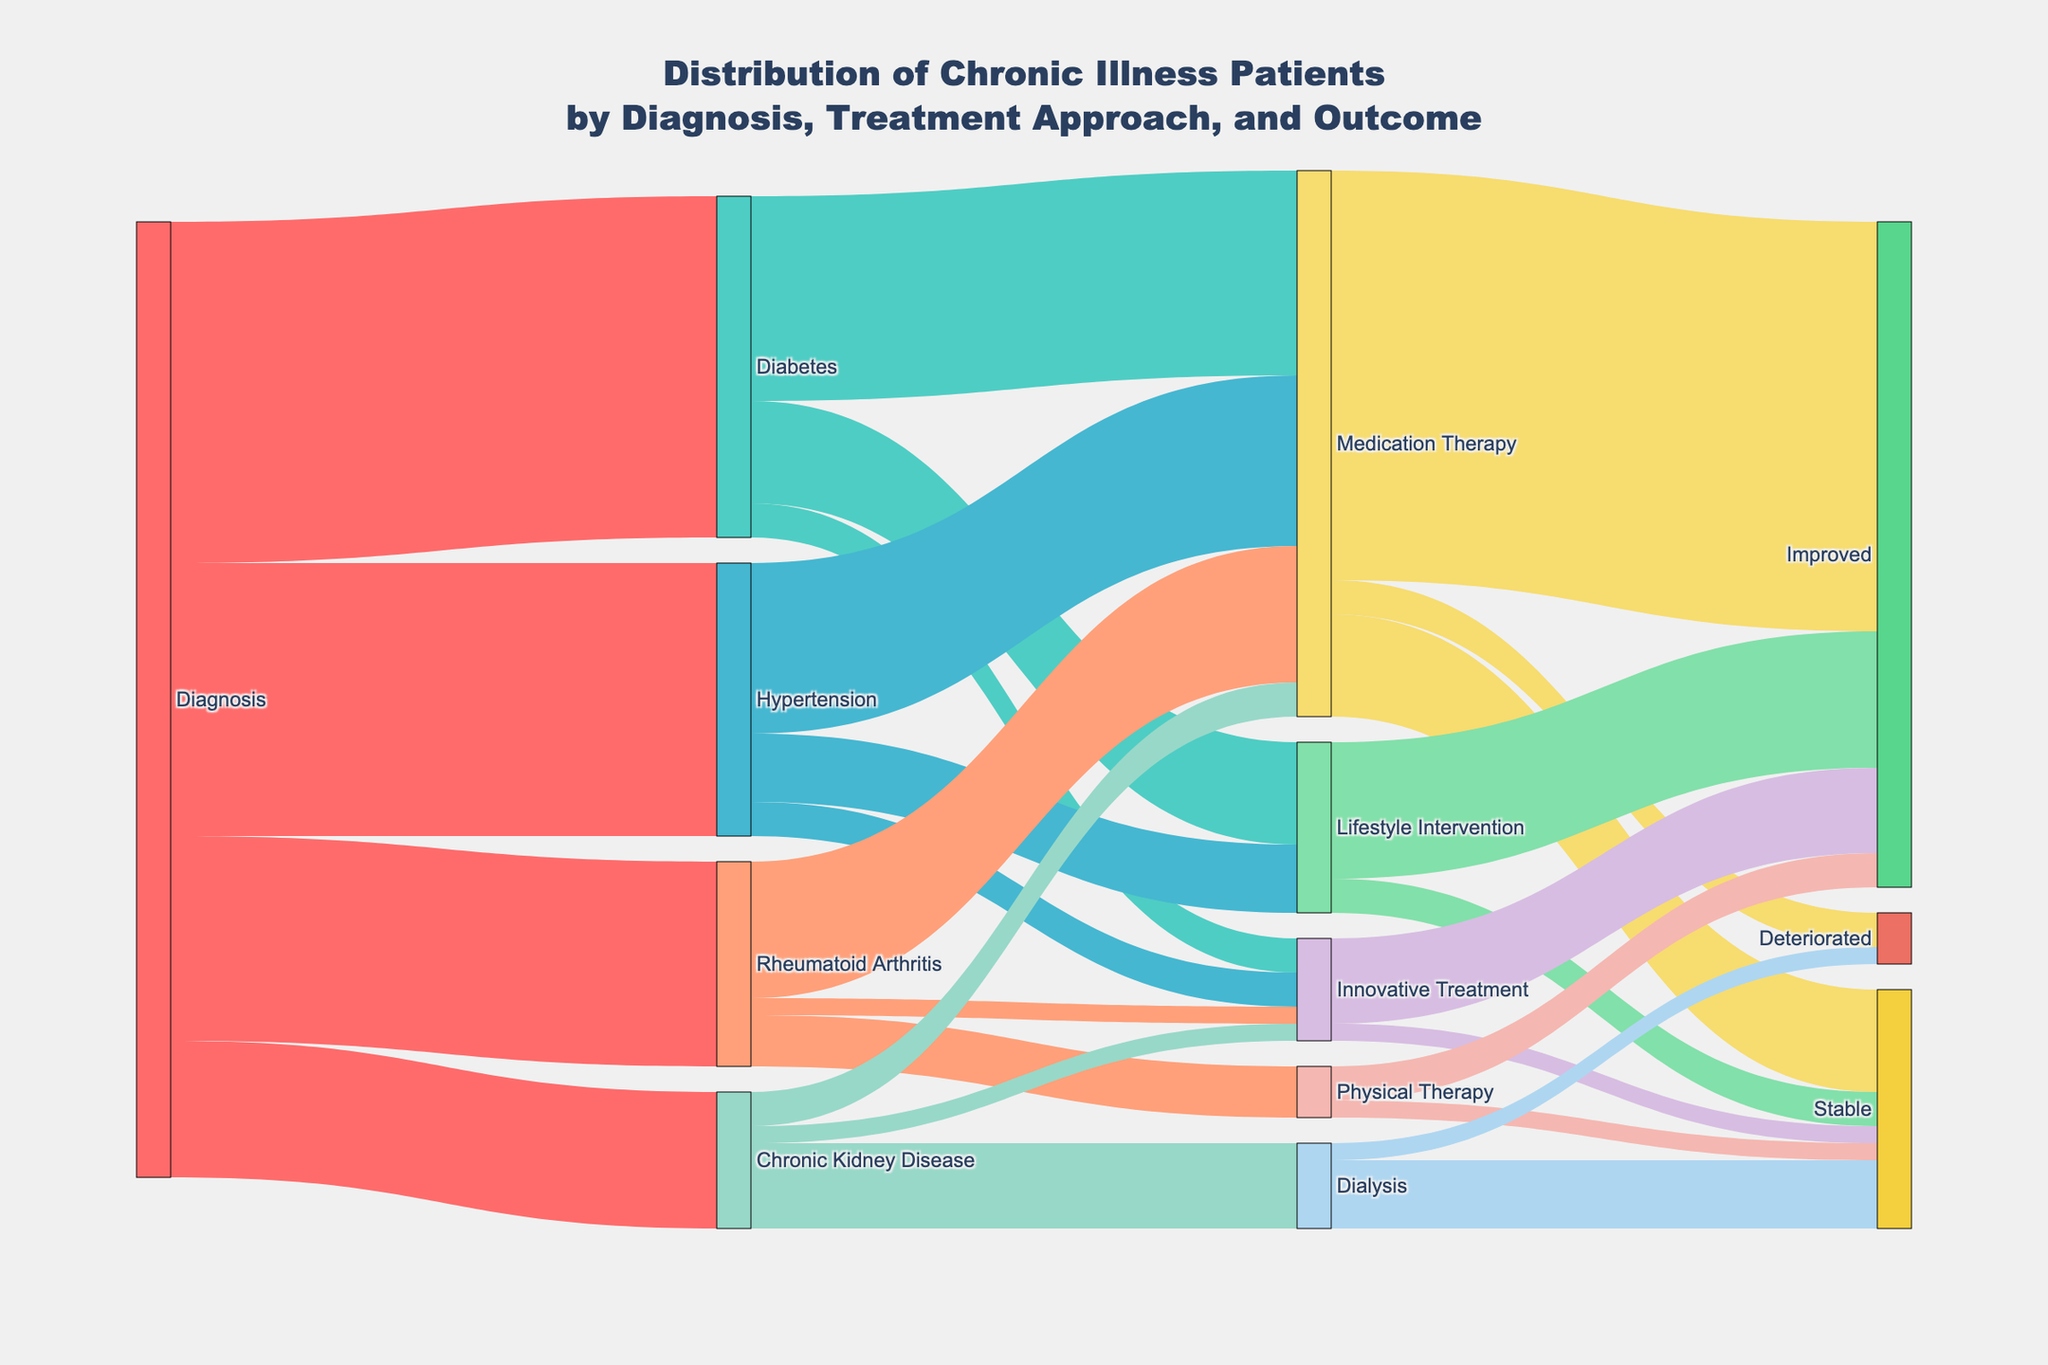What is the total number of patients initially diagnosed with Diabetes? Follow the path from the "Diagnosis" node to "Diabetes" in the Sankey diagram. The value associated with this link is 1000.
Answer: 1000 How many patients underwent Lifestyle Intervention for Hypertension? Trace the "Hypertension" node to the "Lifestyle Intervention" node. The value of the link connecting these two nodes is 200.
Answer: 200 What was the outcome for patients who underwent Dialysis for Chronic Kidney Disease? Identify the links originating from the "Dialysis" node. The values leading to "Stable" and "Deteriorated" are 200 and 50, respectively. Hence, outcomes are "Stable" for 200 patients and "Deteriorated" for 50 patients.
Answer: Stable: 200, Deteriorated: 50 Which treatment approach had the highest number of improved patients? Look at the links leading to the "Improved" outcome from various treatments. Sum the values: Medication Therapy (1200), Lifestyle Intervention (400), Innovative Treatment (250), Physical Therapy (100), and compare them. Medication Therapy has the highest number with 1200.
Answer: Medication Therapy How many patients showed stable outcomes after Physical Therapy? Locate the link between "Physical Therapy" and "Stable" in the Sankey diagram. The value is 50.
Answer: 50 Compare the number of patients who improved after Innovative Treatment to those who improved after Lifestyle Intervention. Which is higher? Identify the values of links leading to "Improved" from "Innovative Treatment" (250) and "Lifestyle Intervention" (400). Compare these values. Lifestyle Intervention has more improved patients.
Answer: Lifestyle Intervention What is the total number of patients undergoing Medication Therapy for all diagnoses? Sum the values from all nodes to the "Medication Therapy" node: Diabetes to Medication Therapy (600), Hypertension to Medication Therapy (500), Rheumatoid Arthritis to Medication Therapy (400), Chronic Kidney Disease to Medication Therapy (100). Total = 600 + 500 + 400 + 100 = 1600.
Answer: 1600 Which treatment approach for Rheumatoid Arthritis had the smallest patient count? Compare the values from the "Rheumatoid Arthritis" node to its treatment approaches: Medication Therapy (400), Physical Therapy (150), Innovative Treatment (50). The smallest is Innovative Treatment with 50 patients.
Answer: Innovative Treatment How many patients in total had an improved outcome across all treatments? Sum the values from all nodes leading to "Improved": Medication Therapy (1200), Lifestyle Intervention (400), Innovative Treatment (250), Physical Therapy (100). Total = 1200 + 400 + 250 + 100 = 1950.
Answer: 1950 What is the number of patients with outcomes that were stable after undergoing Lifestyle Intervention compared to Innovative Treatment? Locate the values from "Lifestyle Intervention" to "Stable" (100) and "Innovative Treatment" to "Stable" (50). Compare these values. Lifestyle Intervention has more with 100 stable outcomes.
Answer: Lifestyle Intervention: 100, Innovative Treatment: 50 